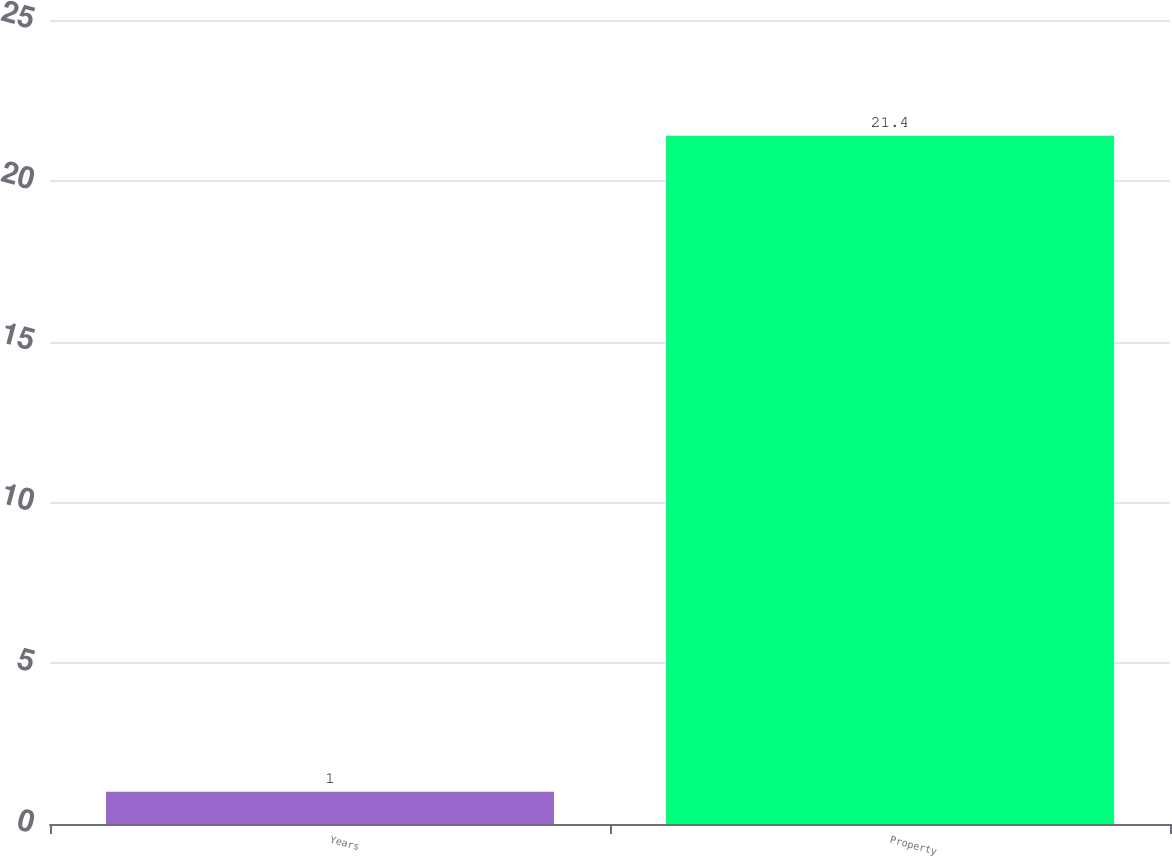Convert chart. <chart><loc_0><loc_0><loc_500><loc_500><bar_chart><fcel>Years<fcel>Property<nl><fcel>1<fcel>21.4<nl></chart> 